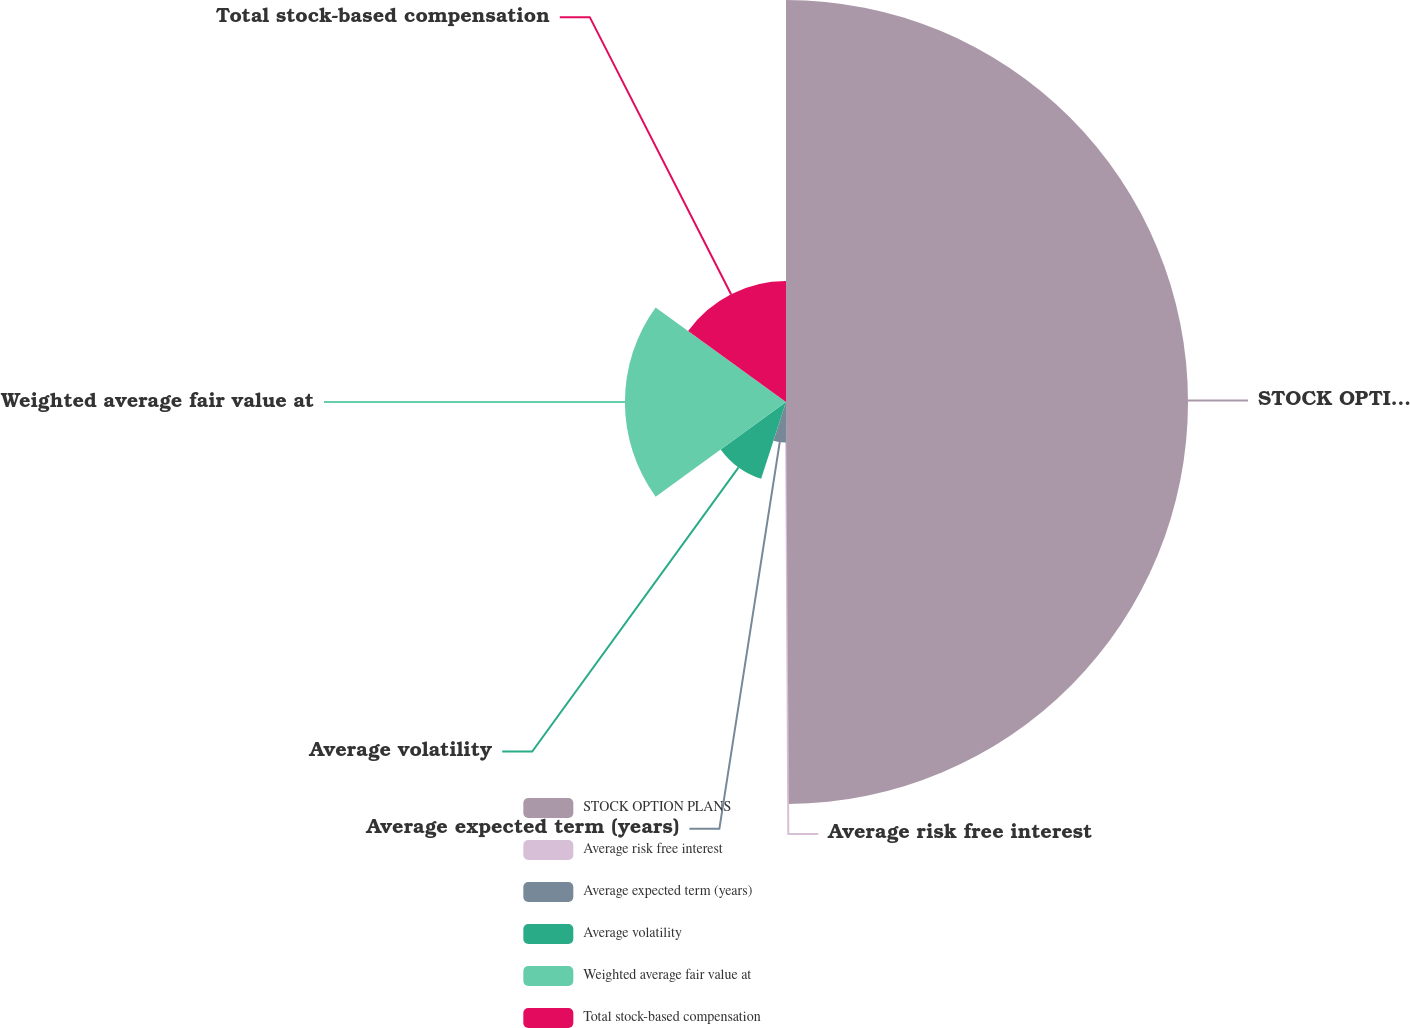Convert chart. <chart><loc_0><loc_0><loc_500><loc_500><pie_chart><fcel>STOCK OPTION PLANS<fcel>Average risk free interest<fcel>Average expected term (years)<fcel>Average volatility<fcel>Weighted average fair value at<fcel>Total stock-based compensation<nl><fcel>49.89%<fcel>0.06%<fcel>5.04%<fcel>10.02%<fcel>19.99%<fcel>15.01%<nl></chart> 